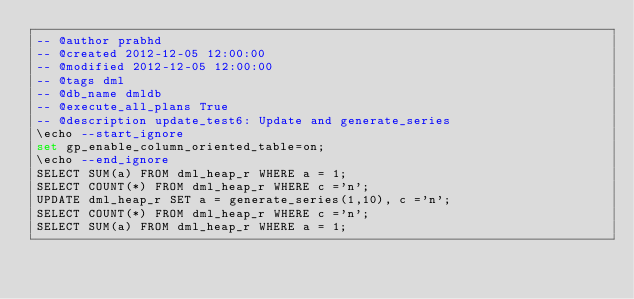<code> <loc_0><loc_0><loc_500><loc_500><_SQL_>-- @author prabhd 
-- @created 2012-12-05 12:00:00 
-- @modified 2012-12-05 12:00:00 
-- @tags dml 
-- @db_name dmldb
-- @execute_all_plans True
-- @description update_test6: Update and generate_series
\echo --start_ignore
set gp_enable_column_oriented_table=on;
\echo --end_ignore
SELECT SUM(a) FROM dml_heap_r WHERE a = 1;
SELECT COUNT(*) FROM dml_heap_r WHERE c ='n';
UPDATE dml_heap_r SET a = generate_series(1,10), c ='n';
SELECT COUNT(*) FROM dml_heap_r WHERE c ='n';
SELECT SUM(a) FROM dml_heap_r WHERE a = 1;
</code> 